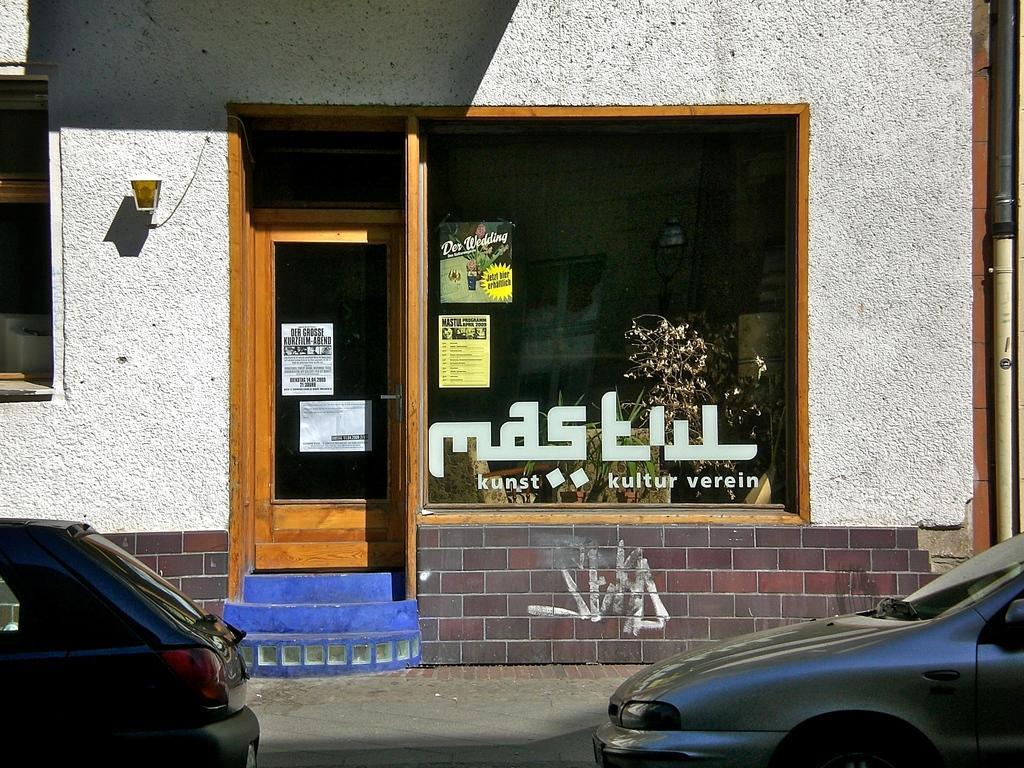Could you give a brief overview of what you see in this image? In this image I can see two cars on the road and a building which is white in color. I can see the door of the building which is brown in color and two posters attached to the door. I can see the glass window of the building to which I can see few poster and through the window I can see few plants and few other objects. To the right side of the image I can see a pipe. 